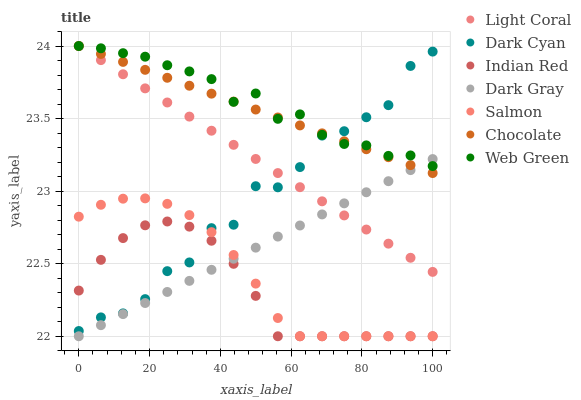Does Indian Red have the minimum area under the curve?
Answer yes or no. Yes. Does Web Green have the maximum area under the curve?
Answer yes or no. Yes. Does Salmon have the minimum area under the curve?
Answer yes or no. No. Does Salmon have the maximum area under the curve?
Answer yes or no. No. Is Dark Gray the smoothest?
Answer yes or no. Yes. Is Dark Cyan the roughest?
Answer yes or no. Yes. Is Salmon the smoothest?
Answer yes or no. No. Is Salmon the roughest?
Answer yes or no. No. Does Dark Gray have the lowest value?
Answer yes or no. Yes. Does Web Green have the lowest value?
Answer yes or no. No. Does Light Coral have the highest value?
Answer yes or no. Yes. Does Salmon have the highest value?
Answer yes or no. No. Is Salmon less than Web Green?
Answer yes or no. Yes. Is Chocolate greater than Indian Red?
Answer yes or no. Yes. Does Chocolate intersect Light Coral?
Answer yes or no. Yes. Is Chocolate less than Light Coral?
Answer yes or no. No. Is Chocolate greater than Light Coral?
Answer yes or no. No. Does Salmon intersect Web Green?
Answer yes or no. No. 